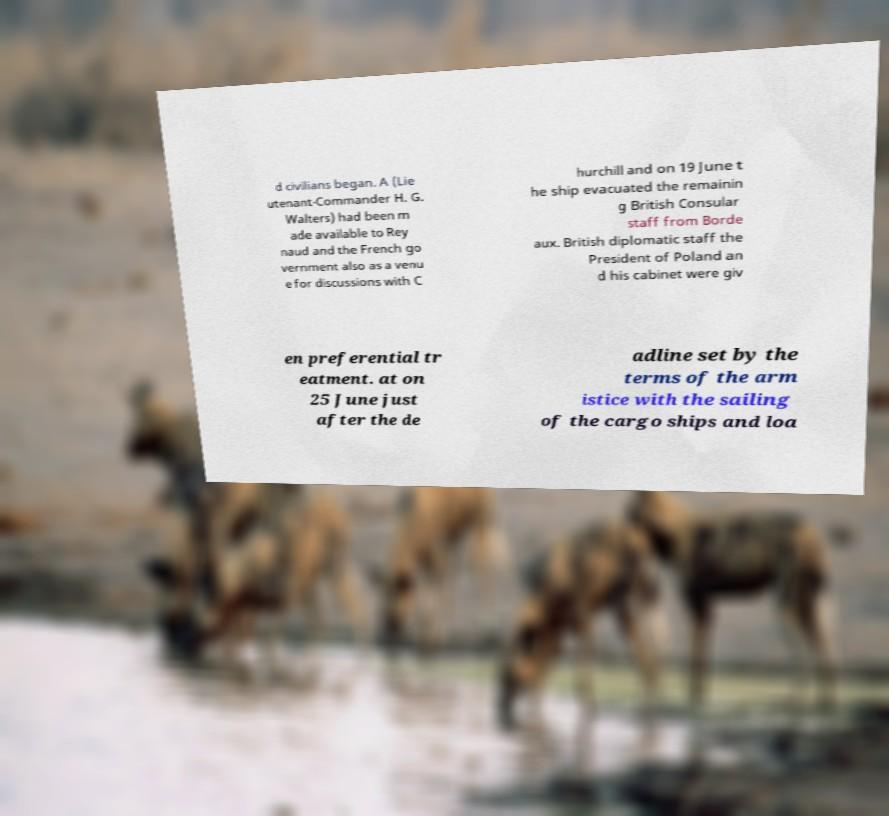I need the written content from this picture converted into text. Can you do that? d civilians began. A (Lie utenant-Commander H. G. Walters) had been m ade available to Rey naud and the French go vernment also as a venu e for discussions with C hurchill and on 19 June t he ship evacuated the remainin g British Consular staff from Borde aux. British diplomatic staff the President of Poland an d his cabinet were giv en preferential tr eatment. at on 25 June just after the de adline set by the terms of the arm istice with the sailing of the cargo ships and loa 